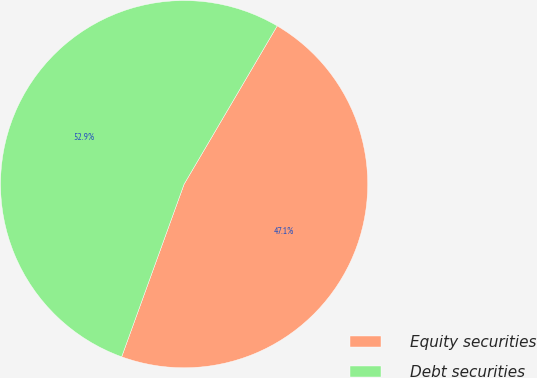<chart> <loc_0><loc_0><loc_500><loc_500><pie_chart><fcel>Equity securities<fcel>Debt securities<nl><fcel>47.06%<fcel>52.94%<nl></chart> 